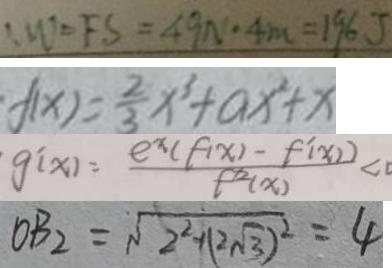<formula> <loc_0><loc_0><loc_500><loc_500>: W ^ { \prime } = F S = 4 9 N ^ { \prime } \cdot 4 m = 1 9 6 J 
 f ( x ) = \frac { 2 } { 3 } x ^ { 3 } + a x ^ { 2 } + x 
 g ^ { \prime } ( x ) = \frac { e ^ { x } ( f ( x ) - f ^ { \prime } ( x ) ) } { f ^ { 2 } ( x ) } < 0 
 O B _ { 2 } = \sqrt { 2 ^ { 2 } + ( 2 \sqrt { 3 } ) ^ { 2 } } = 4</formula> 